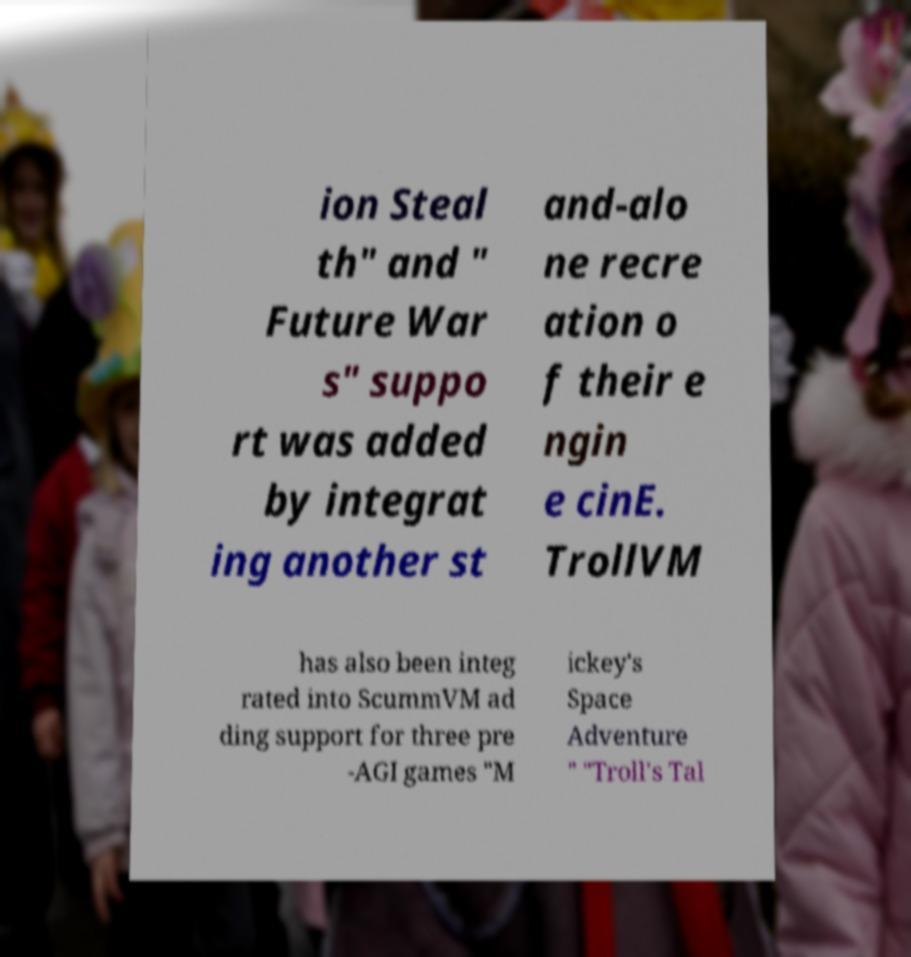Can you accurately transcribe the text from the provided image for me? ion Steal th" and " Future War s" suppo rt was added by integrat ing another st and-alo ne recre ation o f their e ngin e cinE. TrollVM has also been integ rated into ScummVM ad ding support for three pre -AGI games "M ickey's Space Adventure " "Troll's Tal 